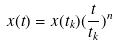Convert formula to latex. <formula><loc_0><loc_0><loc_500><loc_500>x ( t ) = x ( t _ { k } ) ( \frac { t } { t _ { k } } ) ^ { n }</formula> 